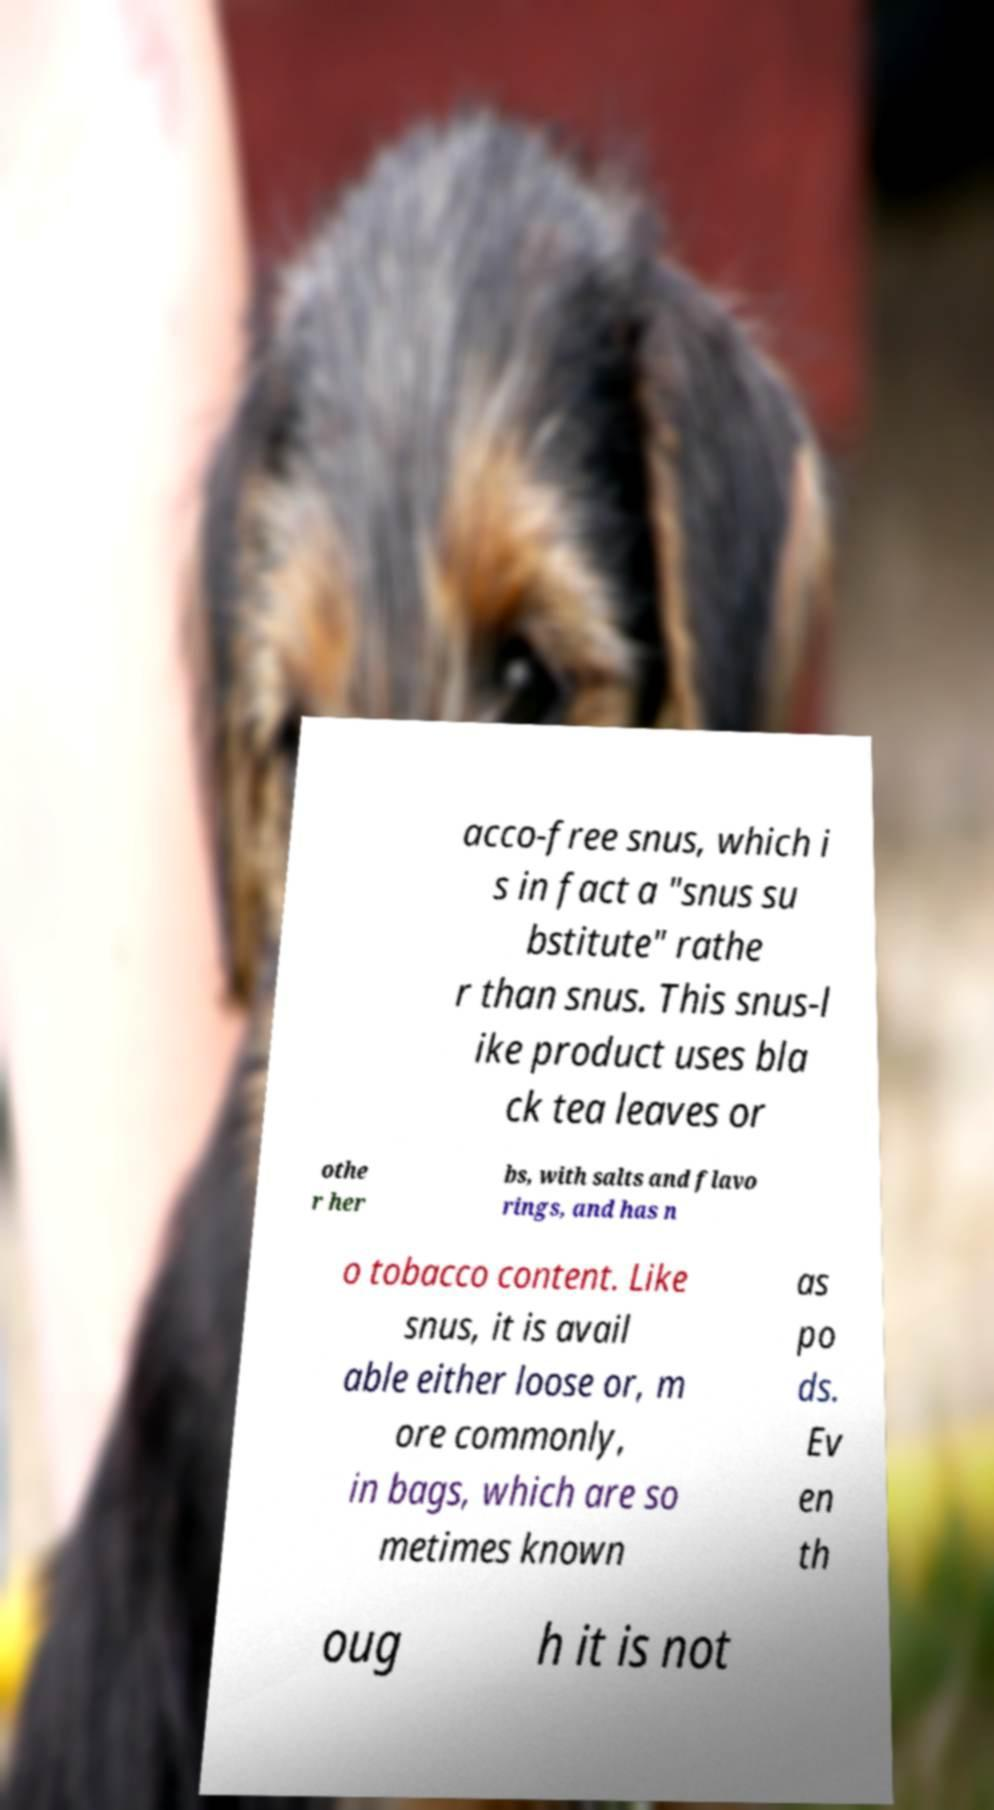Please identify and transcribe the text found in this image. acco-free snus, which i s in fact a "snus su bstitute" rathe r than snus. This snus-l ike product uses bla ck tea leaves or othe r her bs, with salts and flavo rings, and has n o tobacco content. Like snus, it is avail able either loose or, m ore commonly, in bags, which are so metimes known as po ds. Ev en th oug h it is not 